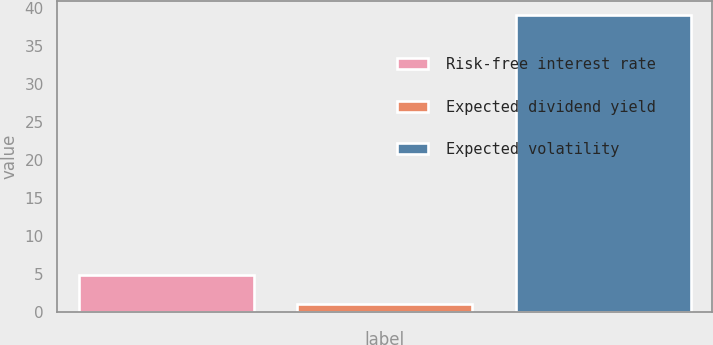<chart> <loc_0><loc_0><loc_500><loc_500><bar_chart><fcel>Risk-free interest rate<fcel>Expected dividend yield<fcel>Expected volatility<nl><fcel>4.82<fcel>1.02<fcel>39<nl></chart> 